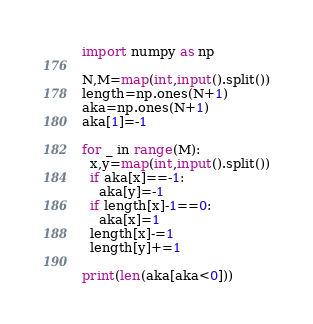<code> <loc_0><loc_0><loc_500><loc_500><_Python_>import numpy as np

N,M=map(int,input().split())
length=np.ones(N+1)
aka=np.ones(N+1)
aka[1]=-1

for _ in range(M):
  x,y=map(int,input().split())
  if aka[x]==-1:
    aka[y]=-1
  if length[x]-1==0:
    aka[x]=1
  length[x]-=1
  length[y]+=1

print(len(aka[aka<0]))</code> 